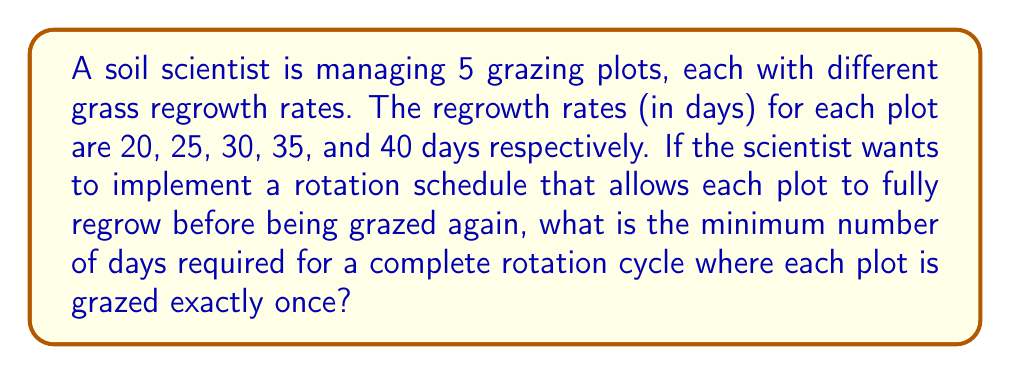Provide a solution to this math problem. To solve this problem, we need to find the least common multiple (LCM) of the regrowth rates. This will ensure that each plot has completed a whole number of regrowth cycles when the rotation is complete.

Let's approach this step-by-step:

1) First, we need to find the prime factorization of each number:
   20 = $2^2 \times 5$
   25 = $5^2$
   30 = $2 \times 3 \times 5$
   35 = $5 \times 7$
   40 = $2^3 \times 5$

2) To find the LCM, we take each prime factor to the highest power in which it occurs in any of the numbers:

   $LCM = 2^3 \times 3 \times 5^2 \times 7$

3) Now let's calculate this:
   $LCM = 8 \times 3 \times 25 \times 7$
   $LCM = 24 \times 25 \times 7$
   $LCM = 600 \times 7$
   $LCM = 4200$

Therefore, the minimum number of days for a complete rotation cycle is 4200 days.

This ensures that:
- Plot 1 has completed 210 regrowth cycles (4200 ÷ 20 = 210)
- Plot 2 has completed 168 regrowth cycles (4200 ÷ 25 = 168)
- Plot 3 has completed 140 regrowth cycles (4200 ÷ 30 = 140)
- Plot 4 has completed 120 regrowth cycles (4200 ÷ 35 = 120)
- Plot 5 has completed 105 regrowth cycles (4200 ÷ 40 = 105)
Answer: The minimum number of days required for a complete rotation cycle is 4200 days. 